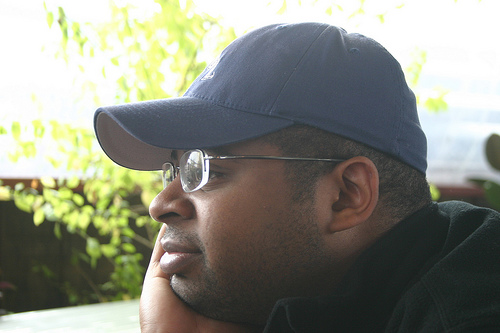<image>
Is there a cap on the man? Yes. Looking at the image, I can see the cap is positioned on top of the man, with the man providing support. Is there a hat to the left of the head? No. The hat is not to the left of the head. From this viewpoint, they have a different horizontal relationship. Is the hat above the man? No. The hat is not positioned above the man. The vertical arrangement shows a different relationship. 